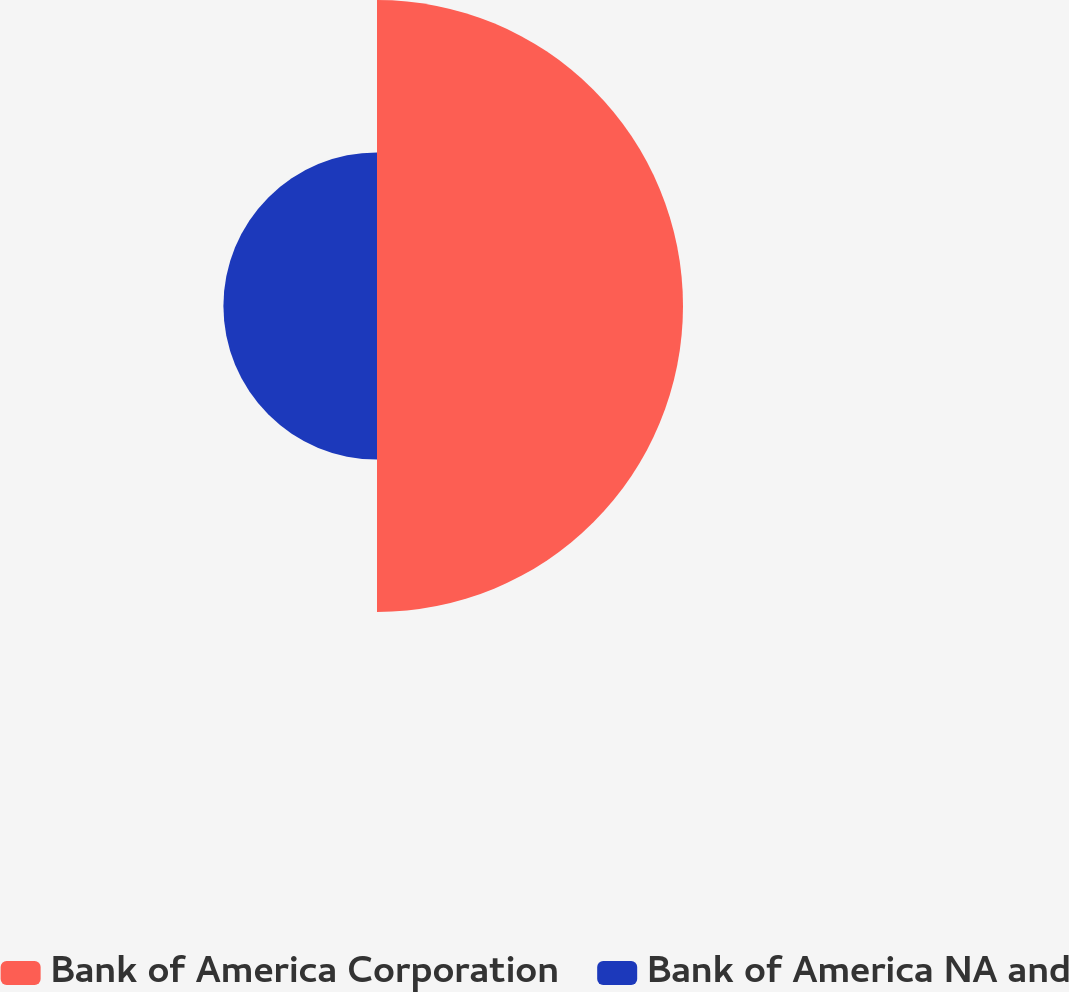Convert chart. <chart><loc_0><loc_0><loc_500><loc_500><pie_chart><fcel>Bank of America Corporation<fcel>Bank of America NA and<nl><fcel>66.58%<fcel>33.42%<nl></chart> 